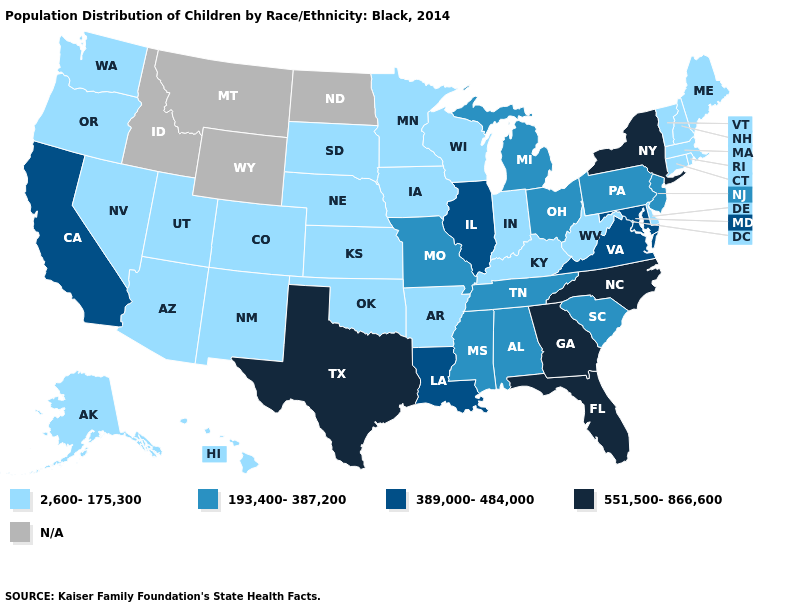What is the value of Iowa?
Keep it brief. 2,600-175,300. Which states have the lowest value in the MidWest?
Be succinct. Indiana, Iowa, Kansas, Minnesota, Nebraska, South Dakota, Wisconsin. Does Florida have the highest value in the USA?
Keep it brief. Yes. Which states have the lowest value in the USA?
Write a very short answer. Alaska, Arizona, Arkansas, Colorado, Connecticut, Delaware, Hawaii, Indiana, Iowa, Kansas, Kentucky, Maine, Massachusetts, Minnesota, Nebraska, Nevada, New Hampshire, New Mexico, Oklahoma, Oregon, Rhode Island, South Dakota, Utah, Vermont, Washington, West Virginia, Wisconsin. Does Texas have the highest value in the USA?
Concise answer only. Yes. What is the lowest value in states that border Virginia?
Concise answer only. 2,600-175,300. Which states hav the highest value in the MidWest?
Give a very brief answer. Illinois. How many symbols are there in the legend?
Answer briefly. 5. Name the states that have a value in the range 2,600-175,300?
Be succinct. Alaska, Arizona, Arkansas, Colorado, Connecticut, Delaware, Hawaii, Indiana, Iowa, Kansas, Kentucky, Maine, Massachusetts, Minnesota, Nebraska, Nevada, New Hampshire, New Mexico, Oklahoma, Oregon, Rhode Island, South Dakota, Utah, Vermont, Washington, West Virginia, Wisconsin. What is the lowest value in the USA?
Answer briefly. 2,600-175,300. Which states have the highest value in the USA?
Keep it brief. Florida, Georgia, New York, North Carolina, Texas. How many symbols are there in the legend?
Answer briefly. 5. Does South Carolina have the highest value in the USA?
Short answer required. No. What is the value of West Virginia?
Keep it brief. 2,600-175,300. Which states have the lowest value in the USA?
Keep it brief. Alaska, Arizona, Arkansas, Colorado, Connecticut, Delaware, Hawaii, Indiana, Iowa, Kansas, Kentucky, Maine, Massachusetts, Minnesota, Nebraska, Nevada, New Hampshire, New Mexico, Oklahoma, Oregon, Rhode Island, South Dakota, Utah, Vermont, Washington, West Virginia, Wisconsin. 